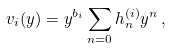<formula> <loc_0><loc_0><loc_500><loc_500>v _ { i } ( y ) = y ^ { b _ { i } } \sum _ { n = 0 } h _ { n } ^ { ( i ) } y ^ { n } \, ,</formula> 